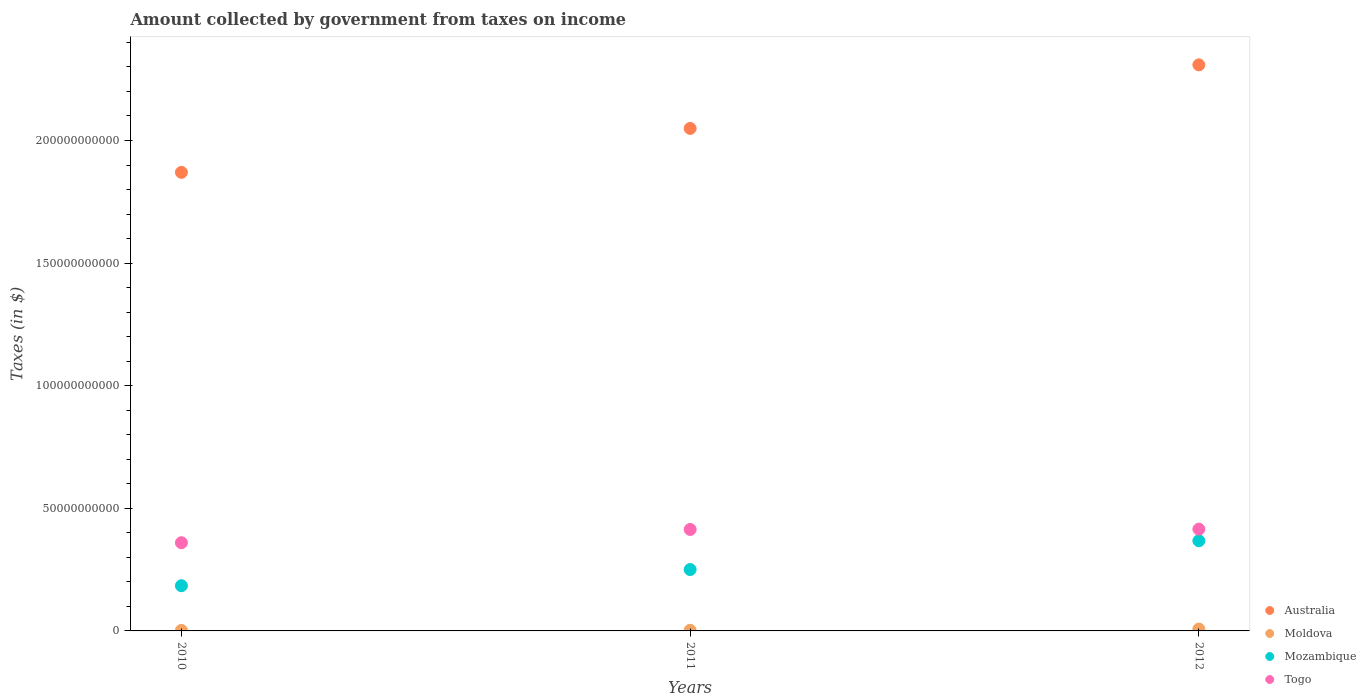Is the number of dotlines equal to the number of legend labels?
Provide a short and direct response. Yes. What is the amount collected by government from taxes on income in Australia in 2012?
Your answer should be compact. 2.31e+11. Across all years, what is the maximum amount collected by government from taxes on income in Mozambique?
Keep it short and to the point. 3.68e+1. Across all years, what is the minimum amount collected by government from taxes on income in Togo?
Offer a terse response. 3.60e+1. In which year was the amount collected by government from taxes on income in Mozambique maximum?
Keep it short and to the point. 2012. What is the total amount collected by government from taxes on income in Moldova in the graph?
Ensure brevity in your answer.  1.24e+09. What is the difference between the amount collected by government from taxes on income in Moldova in 2010 and that in 2011?
Give a very brief answer. -4.28e+07. What is the difference between the amount collected by government from taxes on income in Mozambique in 2012 and the amount collected by government from taxes on income in Australia in 2010?
Make the answer very short. -1.50e+11. What is the average amount collected by government from taxes on income in Australia per year?
Provide a short and direct response. 2.08e+11. In the year 2012, what is the difference between the amount collected by government from taxes on income in Moldova and amount collected by government from taxes on income in Togo?
Your answer should be very brief. -4.07e+1. In how many years, is the amount collected by government from taxes on income in Australia greater than 140000000000 $?
Provide a succinct answer. 3. What is the ratio of the amount collected by government from taxes on income in Mozambique in 2010 to that in 2012?
Provide a short and direct response. 0.5. Is the difference between the amount collected by government from taxes on income in Moldova in 2011 and 2012 greater than the difference between the amount collected by government from taxes on income in Togo in 2011 and 2012?
Provide a succinct answer. No. What is the difference between the highest and the second highest amount collected by government from taxes on income in Australia?
Provide a short and direct response. 2.59e+1. What is the difference between the highest and the lowest amount collected by government from taxes on income in Moldova?
Your response must be concise. 5.55e+08. Is the sum of the amount collected by government from taxes on income in Togo in 2010 and 2012 greater than the maximum amount collected by government from taxes on income in Australia across all years?
Provide a succinct answer. No. Is it the case that in every year, the sum of the amount collected by government from taxes on income in Moldova and amount collected by government from taxes on income in Togo  is greater than the sum of amount collected by government from taxes on income in Mozambique and amount collected by government from taxes on income in Australia?
Offer a very short reply. No. Does the amount collected by government from taxes on income in Mozambique monotonically increase over the years?
Your response must be concise. Yes. Is the amount collected by government from taxes on income in Mozambique strictly greater than the amount collected by government from taxes on income in Moldova over the years?
Ensure brevity in your answer.  Yes. How many dotlines are there?
Offer a terse response. 4. How many years are there in the graph?
Your answer should be compact. 3. What is the difference between two consecutive major ticks on the Y-axis?
Keep it short and to the point. 5.00e+1. Are the values on the major ticks of Y-axis written in scientific E-notation?
Ensure brevity in your answer.  No. How are the legend labels stacked?
Make the answer very short. Vertical. What is the title of the graph?
Your response must be concise. Amount collected by government from taxes on income. What is the label or title of the Y-axis?
Your answer should be compact. Taxes (in $). What is the Taxes (in $) in Australia in 2010?
Your answer should be compact. 1.87e+11. What is the Taxes (in $) of Moldova in 2010?
Offer a very short reply. 2.16e+08. What is the Taxes (in $) in Mozambique in 2010?
Give a very brief answer. 1.84e+1. What is the Taxes (in $) of Togo in 2010?
Ensure brevity in your answer.  3.60e+1. What is the Taxes (in $) in Australia in 2011?
Your answer should be very brief. 2.05e+11. What is the Taxes (in $) in Moldova in 2011?
Your answer should be compact. 2.58e+08. What is the Taxes (in $) in Mozambique in 2011?
Offer a very short reply. 2.50e+1. What is the Taxes (in $) of Togo in 2011?
Offer a very short reply. 4.14e+1. What is the Taxes (in $) of Australia in 2012?
Your answer should be compact. 2.31e+11. What is the Taxes (in $) of Moldova in 2012?
Provide a succinct answer. 7.70e+08. What is the Taxes (in $) of Mozambique in 2012?
Offer a terse response. 3.68e+1. What is the Taxes (in $) of Togo in 2012?
Ensure brevity in your answer.  4.15e+1. Across all years, what is the maximum Taxes (in $) in Australia?
Give a very brief answer. 2.31e+11. Across all years, what is the maximum Taxes (in $) in Moldova?
Your answer should be compact. 7.70e+08. Across all years, what is the maximum Taxes (in $) in Mozambique?
Your answer should be very brief. 3.68e+1. Across all years, what is the maximum Taxes (in $) in Togo?
Provide a succinct answer. 4.15e+1. Across all years, what is the minimum Taxes (in $) of Australia?
Ensure brevity in your answer.  1.87e+11. Across all years, what is the minimum Taxes (in $) in Moldova?
Ensure brevity in your answer.  2.16e+08. Across all years, what is the minimum Taxes (in $) of Mozambique?
Your answer should be compact. 1.84e+1. Across all years, what is the minimum Taxes (in $) in Togo?
Provide a succinct answer. 3.60e+1. What is the total Taxes (in $) in Australia in the graph?
Provide a short and direct response. 6.23e+11. What is the total Taxes (in $) in Moldova in the graph?
Make the answer very short. 1.24e+09. What is the total Taxes (in $) of Mozambique in the graph?
Ensure brevity in your answer.  8.02e+1. What is the total Taxes (in $) in Togo in the graph?
Keep it short and to the point. 1.19e+11. What is the difference between the Taxes (in $) of Australia in 2010 and that in 2011?
Your answer should be very brief. -1.79e+1. What is the difference between the Taxes (in $) in Moldova in 2010 and that in 2011?
Your answer should be very brief. -4.28e+07. What is the difference between the Taxes (in $) of Mozambique in 2010 and that in 2011?
Provide a succinct answer. -6.60e+09. What is the difference between the Taxes (in $) of Togo in 2010 and that in 2011?
Give a very brief answer. -5.41e+09. What is the difference between the Taxes (in $) of Australia in 2010 and that in 2012?
Ensure brevity in your answer.  -4.38e+1. What is the difference between the Taxes (in $) of Moldova in 2010 and that in 2012?
Ensure brevity in your answer.  -5.55e+08. What is the difference between the Taxes (in $) of Mozambique in 2010 and that in 2012?
Offer a terse response. -1.83e+1. What is the difference between the Taxes (in $) of Togo in 2010 and that in 2012?
Your answer should be very brief. -5.55e+09. What is the difference between the Taxes (in $) in Australia in 2011 and that in 2012?
Your answer should be compact. -2.59e+1. What is the difference between the Taxes (in $) of Moldova in 2011 and that in 2012?
Ensure brevity in your answer.  -5.12e+08. What is the difference between the Taxes (in $) of Mozambique in 2011 and that in 2012?
Your answer should be compact. -1.17e+1. What is the difference between the Taxes (in $) in Togo in 2011 and that in 2012?
Ensure brevity in your answer.  -1.35e+08. What is the difference between the Taxes (in $) of Australia in 2010 and the Taxes (in $) of Moldova in 2011?
Keep it short and to the point. 1.87e+11. What is the difference between the Taxes (in $) of Australia in 2010 and the Taxes (in $) of Mozambique in 2011?
Offer a terse response. 1.62e+11. What is the difference between the Taxes (in $) in Australia in 2010 and the Taxes (in $) in Togo in 2011?
Provide a short and direct response. 1.46e+11. What is the difference between the Taxes (in $) of Moldova in 2010 and the Taxes (in $) of Mozambique in 2011?
Your answer should be compact. -2.48e+1. What is the difference between the Taxes (in $) in Moldova in 2010 and the Taxes (in $) in Togo in 2011?
Your response must be concise. -4.12e+1. What is the difference between the Taxes (in $) in Mozambique in 2010 and the Taxes (in $) in Togo in 2011?
Give a very brief answer. -2.29e+1. What is the difference between the Taxes (in $) in Australia in 2010 and the Taxes (in $) in Moldova in 2012?
Your answer should be compact. 1.86e+11. What is the difference between the Taxes (in $) of Australia in 2010 and the Taxes (in $) of Mozambique in 2012?
Offer a terse response. 1.50e+11. What is the difference between the Taxes (in $) in Australia in 2010 and the Taxes (in $) in Togo in 2012?
Provide a short and direct response. 1.45e+11. What is the difference between the Taxes (in $) of Moldova in 2010 and the Taxes (in $) of Mozambique in 2012?
Ensure brevity in your answer.  -3.66e+1. What is the difference between the Taxes (in $) in Moldova in 2010 and the Taxes (in $) in Togo in 2012?
Your answer should be very brief. -4.13e+1. What is the difference between the Taxes (in $) in Mozambique in 2010 and the Taxes (in $) in Togo in 2012?
Give a very brief answer. -2.31e+1. What is the difference between the Taxes (in $) of Australia in 2011 and the Taxes (in $) of Moldova in 2012?
Give a very brief answer. 2.04e+11. What is the difference between the Taxes (in $) of Australia in 2011 and the Taxes (in $) of Mozambique in 2012?
Make the answer very short. 1.68e+11. What is the difference between the Taxes (in $) in Australia in 2011 and the Taxes (in $) in Togo in 2012?
Give a very brief answer. 1.63e+11. What is the difference between the Taxes (in $) in Moldova in 2011 and the Taxes (in $) in Mozambique in 2012?
Give a very brief answer. -3.65e+1. What is the difference between the Taxes (in $) of Moldova in 2011 and the Taxes (in $) of Togo in 2012?
Your response must be concise. -4.13e+1. What is the difference between the Taxes (in $) in Mozambique in 2011 and the Taxes (in $) in Togo in 2012?
Keep it short and to the point. -1.65e+1. What is the average Taxes (in $) of Australia per year?
Ensure brevity in your answer.  2.08e+11. What is the average Taxes (in $) in Moldova per year?
Ensure brevity in your answer.  4.15e+08. What is the average Taxes (in $) in Mozambique per year?
Provide a short and direct response. 2.67e+1. What is the average Taxes (in $) of Togo per year?
Your answer should be compact. 3.96e+1. In the year 2010, what is the difference between the Taxes (in $) in Australia and Taxes (in $) in Moldova?
Give a very brief answer. 1.87e+11. In the year 2010, what is the difference between the Taxes (in $) of Australia and Taxes (in $) of Mozambique?
Provide a short and direct response. 1.69e+11. In the year 2010, what is the difference between the Taxes (in $) in Australia and Taxes (in $) in Togo?
Offer a terse response. 1.51e+11. In the year 2010, what is the difference between the Taxes (in $) of Moldova and Taxes (in $) of Mozambique?
Provide a succinct answer. -1.82e+1. In the year 2010, what is the difference between the Taxes (in $) of Moldova and Taxes (in $) of Togo?
Provide a short and direct response. -3.58e+1. In the year 2010, what is the difference between the Taxes (in $) of Mozambique and Taxes (in $) of Togo?
Offer a very short reply. -1.75e+1. In the year 2011, what is the difference between the Taxes (in $) in Australia and Taxes (in $) in Moldova?
Your response must be concise. 2.05e+11. In the year 2011, what is the difference between the Taxes (in $) in Australia and Taxes (in $) in Mozambique?
Provide a short and direct response. 1.80e+11. In the year 2011, what is the difference between the Taxes (in $) of Australia and Taxes (in $) of Togo?
Offer a very short reply. 1.64e+11. In the year 2011, what is the difference between the Taxes (in $) of Moldova and Taxes (in $) of Mozambique?
Provide a succinct answer. -2.48e+1. In the year 2011, what is the difference between the Taxes (in $) of Moldova and Taxes (in $) of Togo?
Ensure brevity in your answer.  -4.11e+1. In the year 2011, what is the difference between the Taxes (in $) in Mozambique and Taxes (in $) in Togo?
Offer a terse response. -1.63e+1. In the year 2012, what is the difference between the Taxes (in $) of Australia and Taxes (in $) of Moldova?
Your response must be concise. 2.30e+11. In the year 2012, what is the difference between the Taxes (in $) of Australia and Taxes (in $) of Mozambique?
Your response must be concise. 1.94e+11. In the year 2012, what is the difference between the Taxes (in $) in Australia and Taxes (in $) in Togo?
Offer a terse response. 1.89e+11. In the year 2012, what is the difference between the Taxes (in $) of Moldova and Taxes (in $) of Mozambique?
Your response must be concise. -3.60e+1. In the year 2012, what is the difference between the Taxes (in $) in Moldova and Taxes (in $) in Togo?
Your answer should be compact. -4.07e+1. In the year 2012, what is the difference between the Taxes (in $) of Mozambique and Taxes (in $) of Togo?
Your answer should be compact. -4.74e+09. What is the ratio of the Taxes (in $) in Australia in 2010 to that in 2011?
Offer a terse response. 0.91. What is the ratio of the Taxes (in $) of Moldova in 2010 to that in 2011?
Keep it short and to the point. 0.83. What is the ratio of the Taxes (in $) of Mozambique in 2010 to that in 2011?
Keep it short and to the point. 0.74. What is the ratio of the Taxes (in $) of Togo in 2010 to that in 2011?
Give a very brief answer. 0.87. What is the ratio of the Taxes (in $) of Australia in 2010 to that in 2012?
Make the answer very short. 0.81. What is the ratio of the Taxes (in $) of Moldova in 2010 to that in 2012?
Offer a terse response. 0.28. What is the ratio of the Taxes (in $) in Mozambique in 2010 to that in 2012?
Offer a very short reply. 0.5. What is the ratio of the Taxes (in $) in Togo in 2010 to that in 2012?
Offer a terse response. 0.87. What is the ratio of the Taxes (in $) in Australia in 2011 to that in 2012?
Make the answer very short. 0.89. What is the ratio of the Taxes (in $) of Moldova in 2011 to that in 2012?
Ensure brevity in your answer.  0.34. What is the ratio of the Taxes (in $) of Mozambique in 2011 to that in 2012?
Ensure brevity in your answer.  0.68. What is the ratio of the Taxes (in $) in Togo in 2011 to that in 2012?
Ensure brevity in your answer.  1. What is the difference between the highest and the second highest Taxes (in $) in Australia?
Your response must be concise. 2.59e+1. What is the difference between the highest and the second highest Taxes (in $) in Moldova?
Give a very brief answer. 5.12e+08. What is the difference between the highest and the second highest Taxes (in $) of Mozambique?
Offer a very short reply. 1.17e+1. What is the difference between the highest and the second highest Taxes (in $) of Togo?
Offer a very short reply. 1.35e+08. What is the difference between the highest and the lowest Taxes (in $) in Australia?
Ensure brevity in your answer.  4.38e+1. What is the difference between the highest and the lowest Taxes (in $) of Moldova?
Keep it short and to the point. 5.55e+08. What is the difference between the highest and the lowest Taxes (in $) of Mozambique?
Your answer should be very brief. 1.83e+1. What is the difference between the highest and the lowest Taxes (in $) in Togo?
Ensure brevity in your answer.  5.55e+09. 